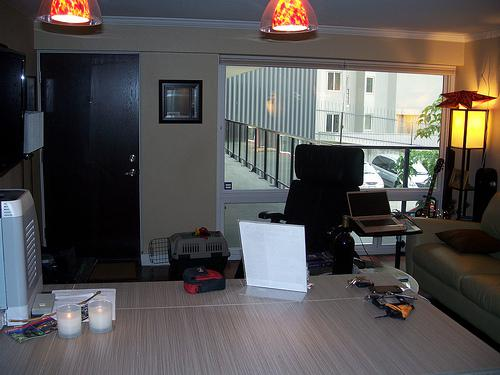Question: what is glowing from the ceiling?
Choices:
A. Glow in the dark sticker.
B. Green goo.
C. Lights.
D. The sun.
Answer with the letter. Answer: C Question: how many lights are on?
Choices:
A. 3.
B. 2.
C. 1.
D. 4.
Answer with the letter. Answer: A Question: when was this photo taken?
Choices:
A. At night.
B. At noon.
C. In the morning.
D. Daylight.
Answer with the letter. Answer: D Question: where was this photo taken?
Choices:
A. Kitchen.
B. Bathroom.
C. Living room.
D. Bedroom.
Answer with the letter. Answer: C Question: what is sitting by the door?
Choices:
A. Pet Carrier.
B. Shoes.
C. Mail.
D. Dog.
Answer with the letter. Answer: A 